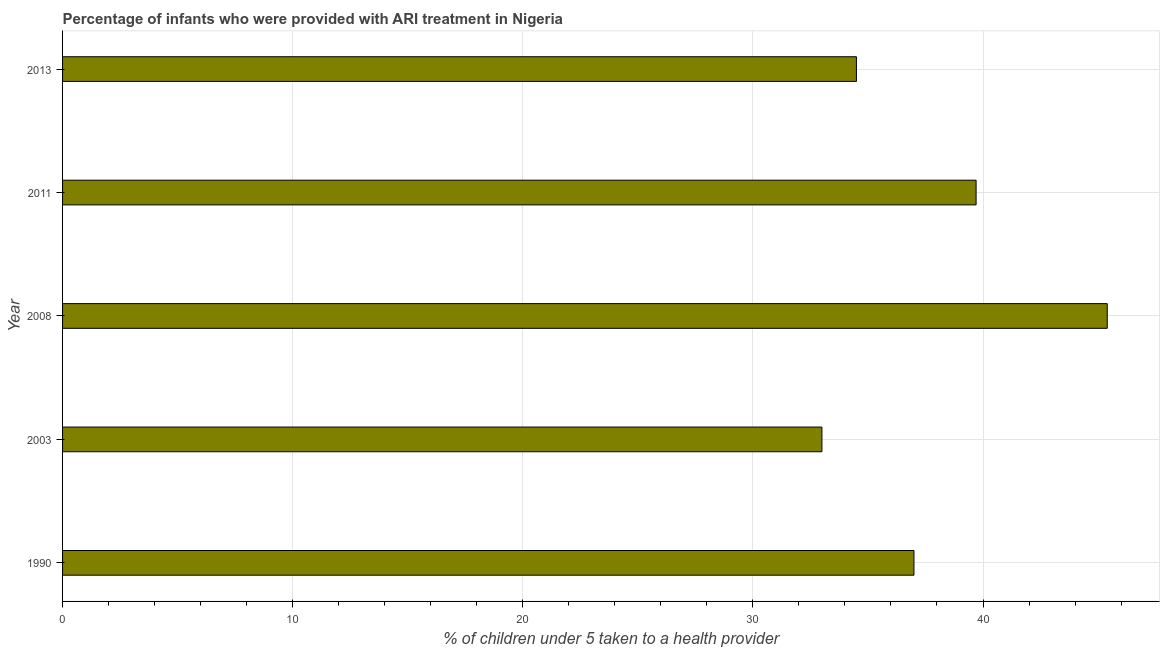Does the graph contain grids?
Offer a very short reply. Yes. What is the title of the graph?
Provide a short and direct response. Percentage of infants who were provided with ARI treatment in Nigeria. What is the label or title of the X-axis?
Offer a very short reply. % of children under 5 taken to a health provider. Across all years, what is the maximum percentage of children who were provided with ari treatment?
Give a very brief answer. 45.4. Across all years, what is the minimum percentage of children who were provided with ari treatment?
Keep it short and to the point. 33. What is the sum of the percentage of children who were provided with ari treatment?
Keep it short and to the point. 189.6. What is the average percentage of children who were provided with ari treatment per year?
Ensure brevity in your answer.  37.92. Do a majority of the years between 2008 and 2013 (inclusive) have percentage of children who were provided with ari treatment greater than 6 %?
Provide a short and direct response. Yes. What is the ratio of the percentage of children who were provided with ari treatment in 2003 to that in 2008?
Provide a short and direct response. 0.73. Is the percentage of children who were provided with ari treatment in 1990 less than that in 2003?
Offer a very short reply. No. Is the difference between the percentage of children who were provided with ari treatment in 1990 and 2003 greater than the difference between any two years?
Keep it short and to the point. No. What is the difference between the highest and the second highest percentage of children who were provided with ari treatment?
Your answer should be compact. 5.7. How many years are there in the graph?
Give a very brief answer. 5. What is the difference between two consecutive major ticks on the X-axis?
Your response must be concise. 10. Are the values on the major ticks of X-axis written in scientific E-notation?
Offer a very short reply. No. What is the % of children under 5 taken to a health provider in 2003?
Offer a very short reply. 33. What is the % of children under 5 taken to a health provider in 2008?
Offer a terse response. 45.4. What is the % of children under 5 taken to a health provider in 2011?
Offer a very short reply. 39.7. What is the % of children under 5 taken to a health provider in 2013?
Provide a succinct answer. 34.5. What is the difference between the % of children under 5 taken to a health provider in 1990 and 2008?
Provide a short and direct response. -8.4. What is the difference between the % of children under 5 taken to a health provider in 2003 and 2008?
Offer a terse response. -12.4. What is the difference between the % of children under 5 taken to a health provider in 2003 and 2013?
Give a very brief answer. -1.5. What is the difference between the % of children under 5 taken to a health provider in 2008 and 2013?
Ensure brevity in your answer.  10.9. What is the difference between the % of children under 5 taken to a health provider in 2011 and 2013?
Ensure brevity in your answer.  5.2. What is the ratio of the % of children under 5 taken to a health provider in 1990 to that in 2003?
Provide a short and direct response. 1.12. What is the ratio of the % of children under 5 taken to a health provider in 1990 to that in 2008?
Provide a succinct answer. 0.81. What is the ratio of the % of children under 5 taken to a health provider in 1990 to that in 2011?
Offer a terse response. 0.93. What is the ratio of the % of children under 5 taken to a health provider in 1990 to that in 2013?
Give a very brief answer. 1.07. What is the ratio of the % of children under 5 taken to a health provider in 2003 to that in 2008?
Provide a short and direct response. 0.73. What is the ratio of the % of children under 5 taken to a health provider in 2003 to that in 2011?
Give a very brief answer. 0.83. What is the ratio of the % of children under 5 taken to a health provider in 2008 to that in 2011?
Ensure brevity in your answer.  1.14. What is the ratio of the % of children under 5 taken to a health provider in 2008 to that in 2013?
Offer a terse response. 1.32. What is the ratio of the % of children under 5 taken to a health provider in 2011 to that in 2013?
Your answer should be compact. 1.15. 